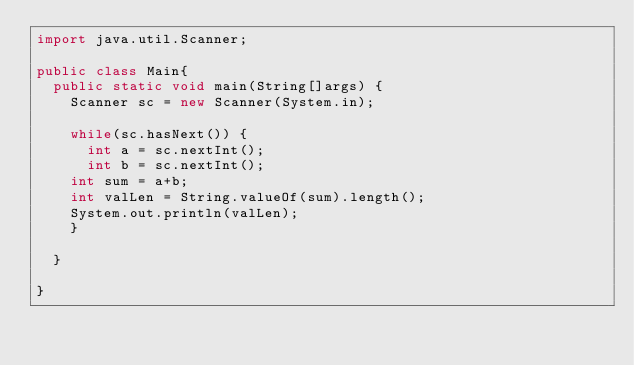<code> <loc_0><loc_0><loc_500><loc_500><_Java_>import java.util.Scanner;

public class Main{
	public static void main(String[]args) {
		Scanner sc = new Scanner(System.in);

		while(sc.hasNext()) {
			int a = sc.nextInt();
			int b = sc.nextInt();
		int sum = a+b;
		int valLen = String.valueOf(sum).length();
		System.out.println(valLen);
		}

	}

}
</code> 